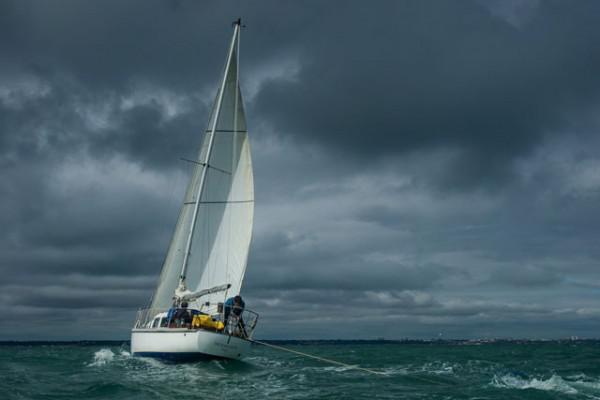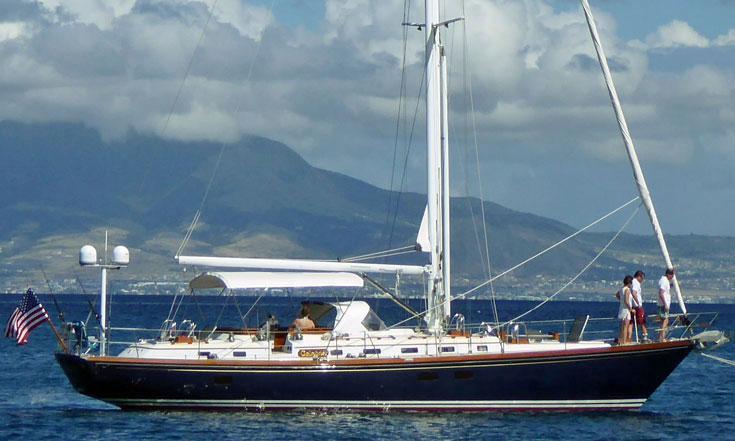The first image is the image on the left, the second image is the image on the right. Given the left and right images, does the statement "One sailboat is on the open water with its sails folded down." hold true? Answer yes or no. Yes. The first image is the image on the left, the second image is the image on the right. Considering the images on both sides, is "The left and right image contains the same number of sailboats sailing with at least one with no sails out." valid? Answer yes or no. Yes. 